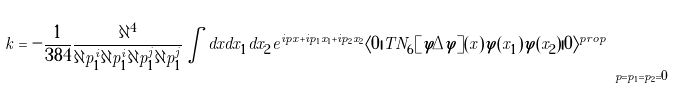Convert formula to latex. <formula><loc_0><loc_0><loc_500><loc_500>k = - \frac { 1 } { 3 8 4 } \frac { \partial ^ { 4 } } { \partial p _ { 1 } ^ { i } \partial p _ { 1 } ^ { i } \partial p _ { 1 } ^ { j } \partial p _ { 1 } ^ { j } } \int d x d x _ { 1 } d x _ { 2 } e ^ { i p x + i p _ { 1 } x _ { 1 } + i p _ { 2 } x _ { 2 } } \langle 0 | T N _ { 6 } [ \varphi \Delta \varphi ] ( x ) \varphi ( x _ { 1 } ) \varphi ( x _ { 2 } ) | 0 \rangle ^ { p r o p } \Big { | } _ { p = p _ { 1 } = p _ { 2 } = 0 }</formula> 